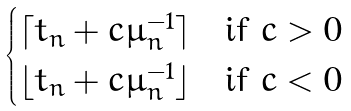Convert formula to latex. <formula><loc_0><loc_0><loc_500><loc_500>\begin{cases} \lceil t _ { n } + c \mu _ { n } ^ { - 1 } \rceil & \text {if   $c>0$} \\ \lfloor t _ { n } + c \mu _ { n } ^ { - 1 } \rfloor & \text {if   $c<0$} \end{cases}</formula> 